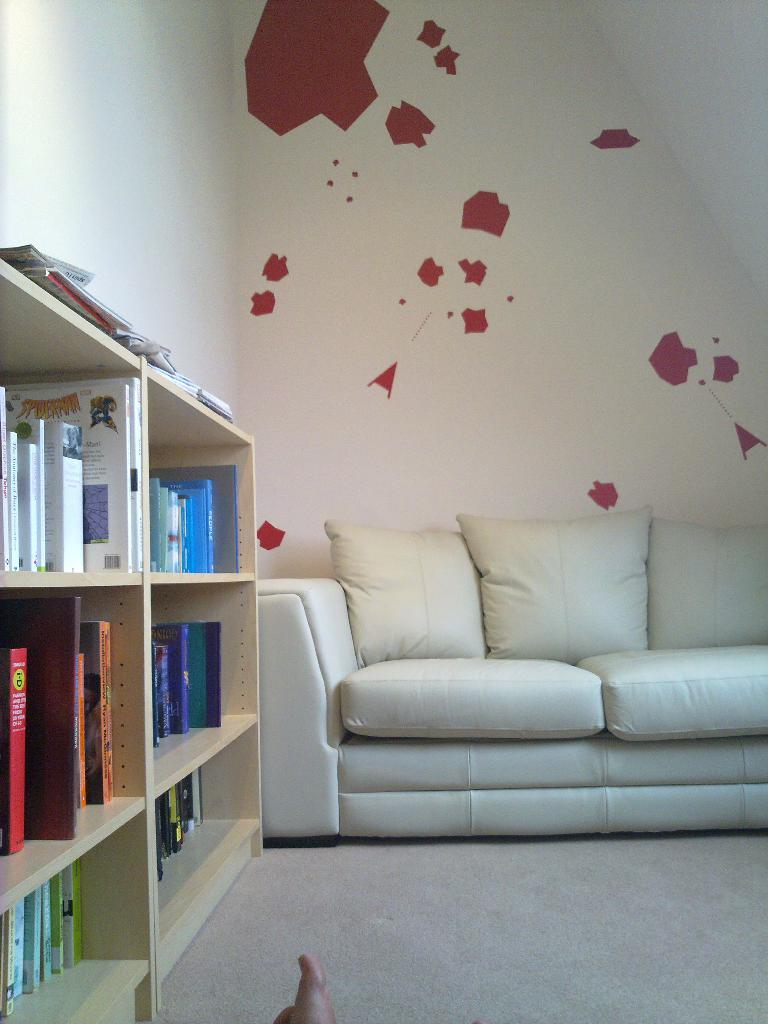What type of furniture is in the image? There is a white couch in the image. What can be seen on the wooden shelf in the image? There are books on the wooden shelf in the image. What is visible in the background of the image? There is a wall visible in the background of the image. What color is the wall in the image? The wall has a red paint. How does the visitor interact with the wheel in the image? There is no wheel present in the image, so it is not possible to answer that question. 